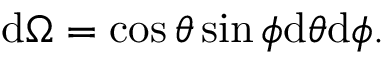<formula> <loc_0><loc_0><loc_500><loc_500>d \Omega = \cos \theta \sin \phi d \theta d \phi .</formula> 